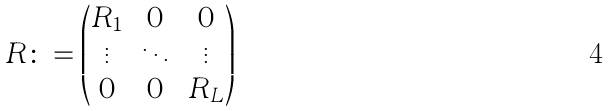Convert formula to latex. <formula><loc_0><loc_0><loc_500><loc_500>R \colon = \begin{pmatrix} R _ { 1 } & 0 & 0 \\ \vdots & \ddots & \vdots \\ 0 & 0 & R _ { L } \end{pmatrix}</formula> 